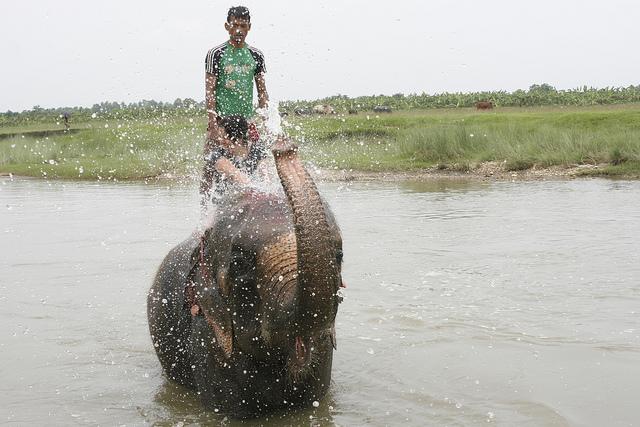Can you see the elephant's legs in the photo?
Keep it brief. No. How many people are on the elephant?
Write a very short answer. 2. What is the nationality of the people on the elephant?
Short answer required. Indian. 